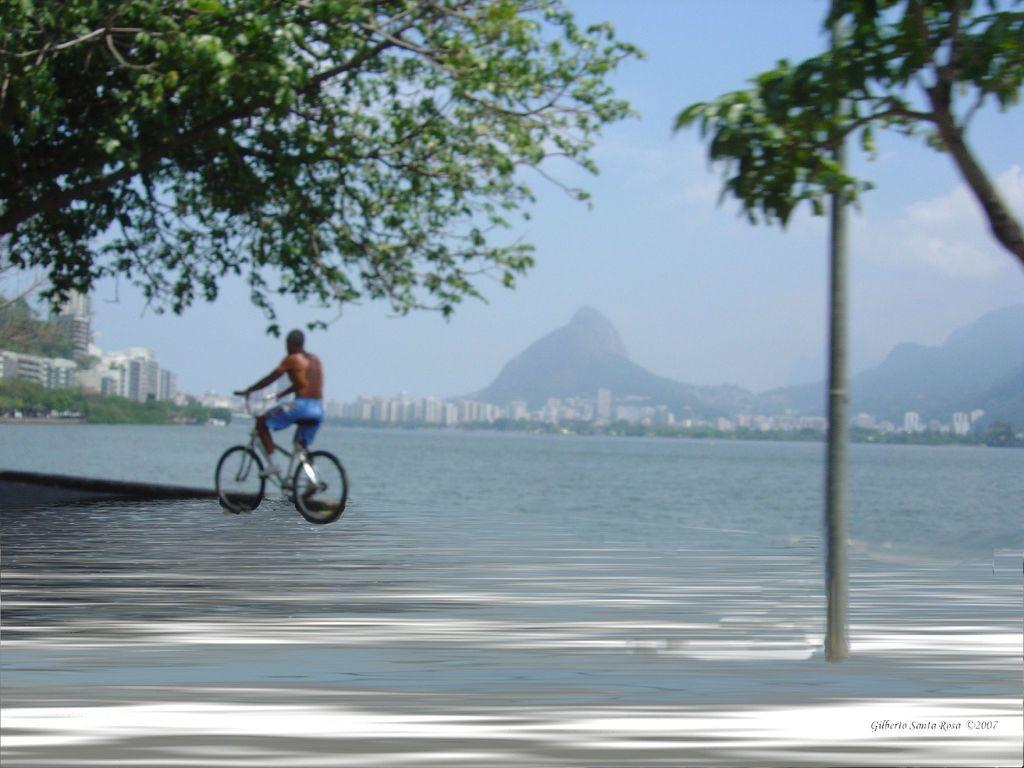In one or two sentences, can you explain what this image depicts? In the image there is a man riding a bicycle on water. On right side we can see a pole and tree with green leaves. On left side we can see some building and trees, in background there are rocks,buildings and sky is on top. 